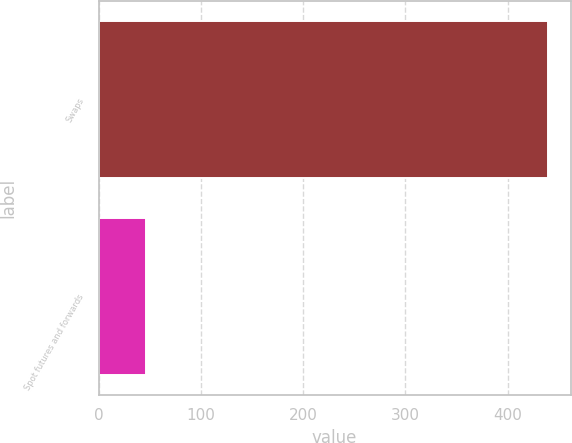Convert chart. <chart><loc_0><loc_0><loc_500><loc_500><bar_chart><fcel>Swaps<fcel>Spot futures and forwards<nl><fcel>439.6<fcel>46<nl></chart> 